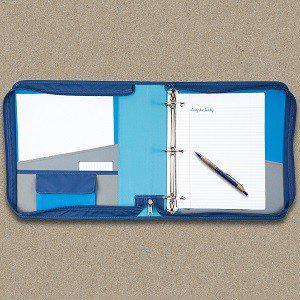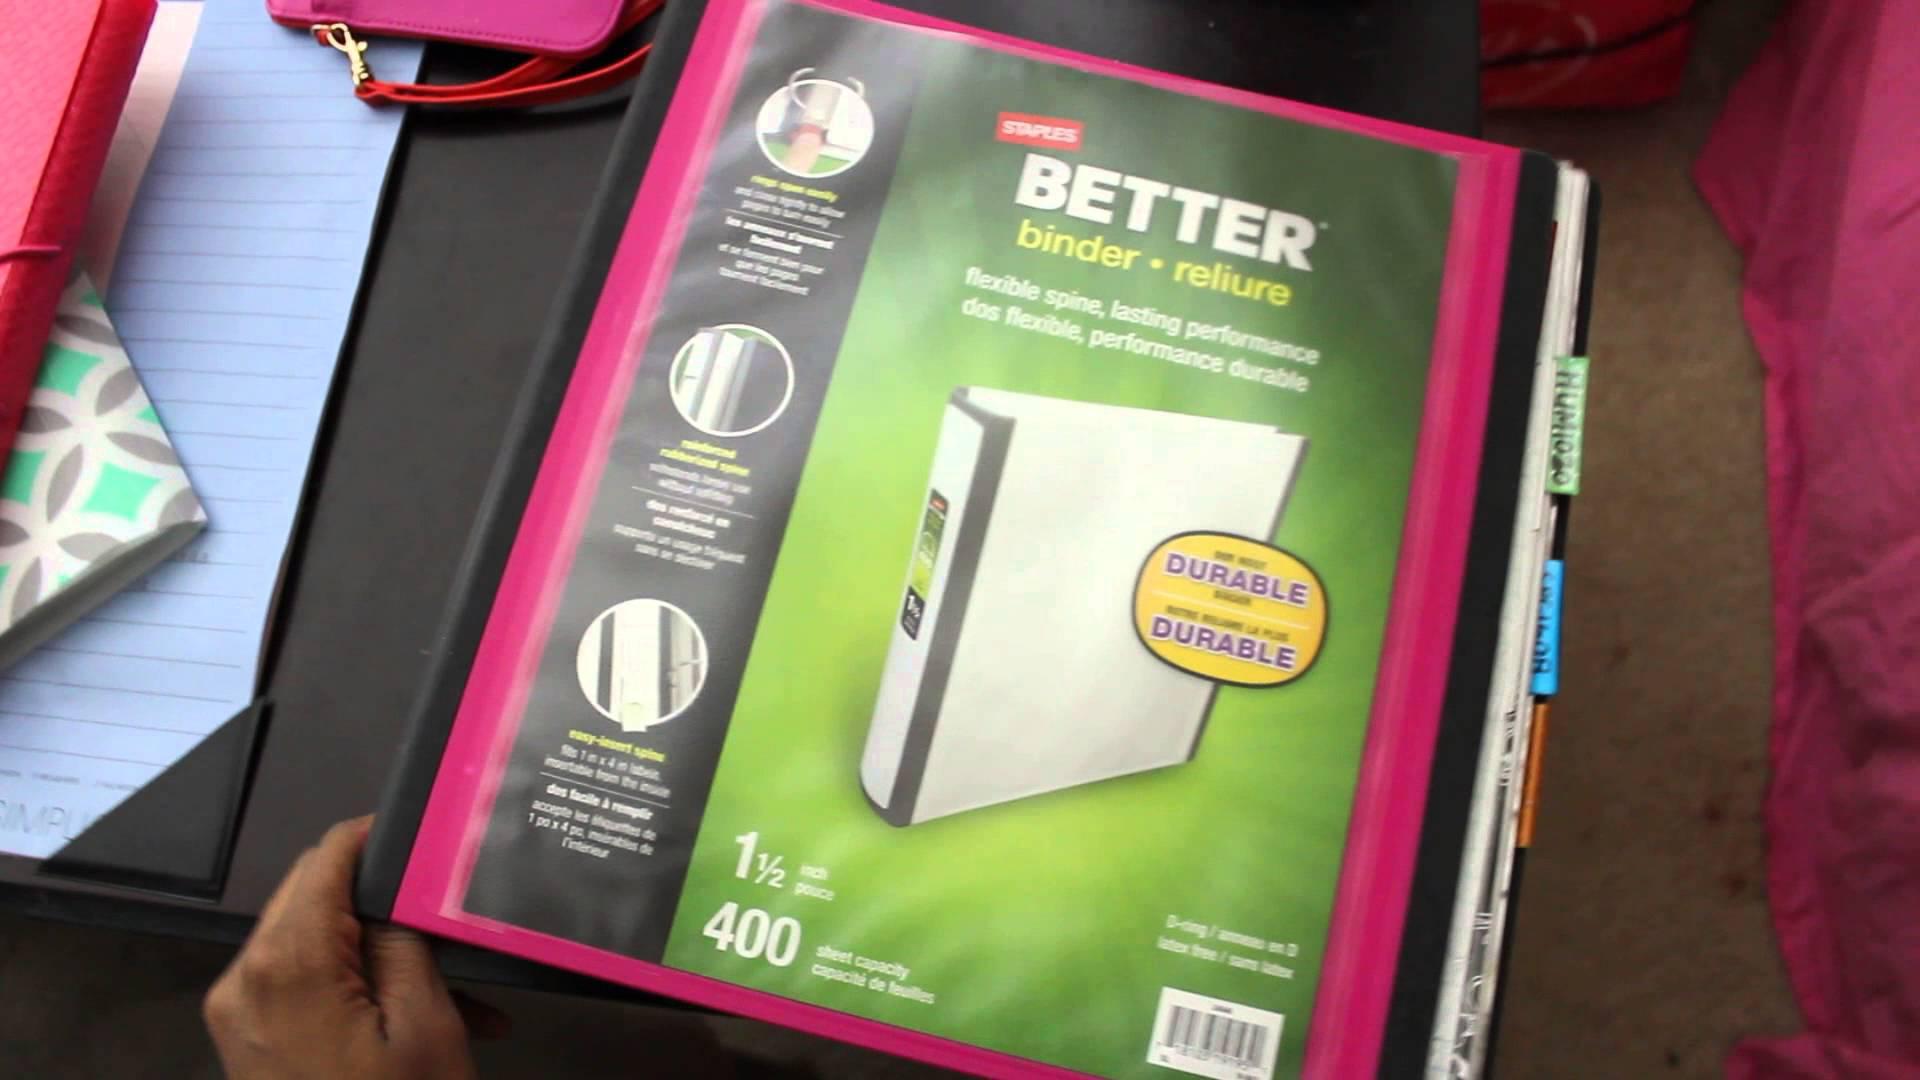The first image is the image on the left, the second image is the image on the right. Assess this claim about the two images: "The left image shows one blue-toned binder.". Correct or not? Answer yes or no. Yes. 